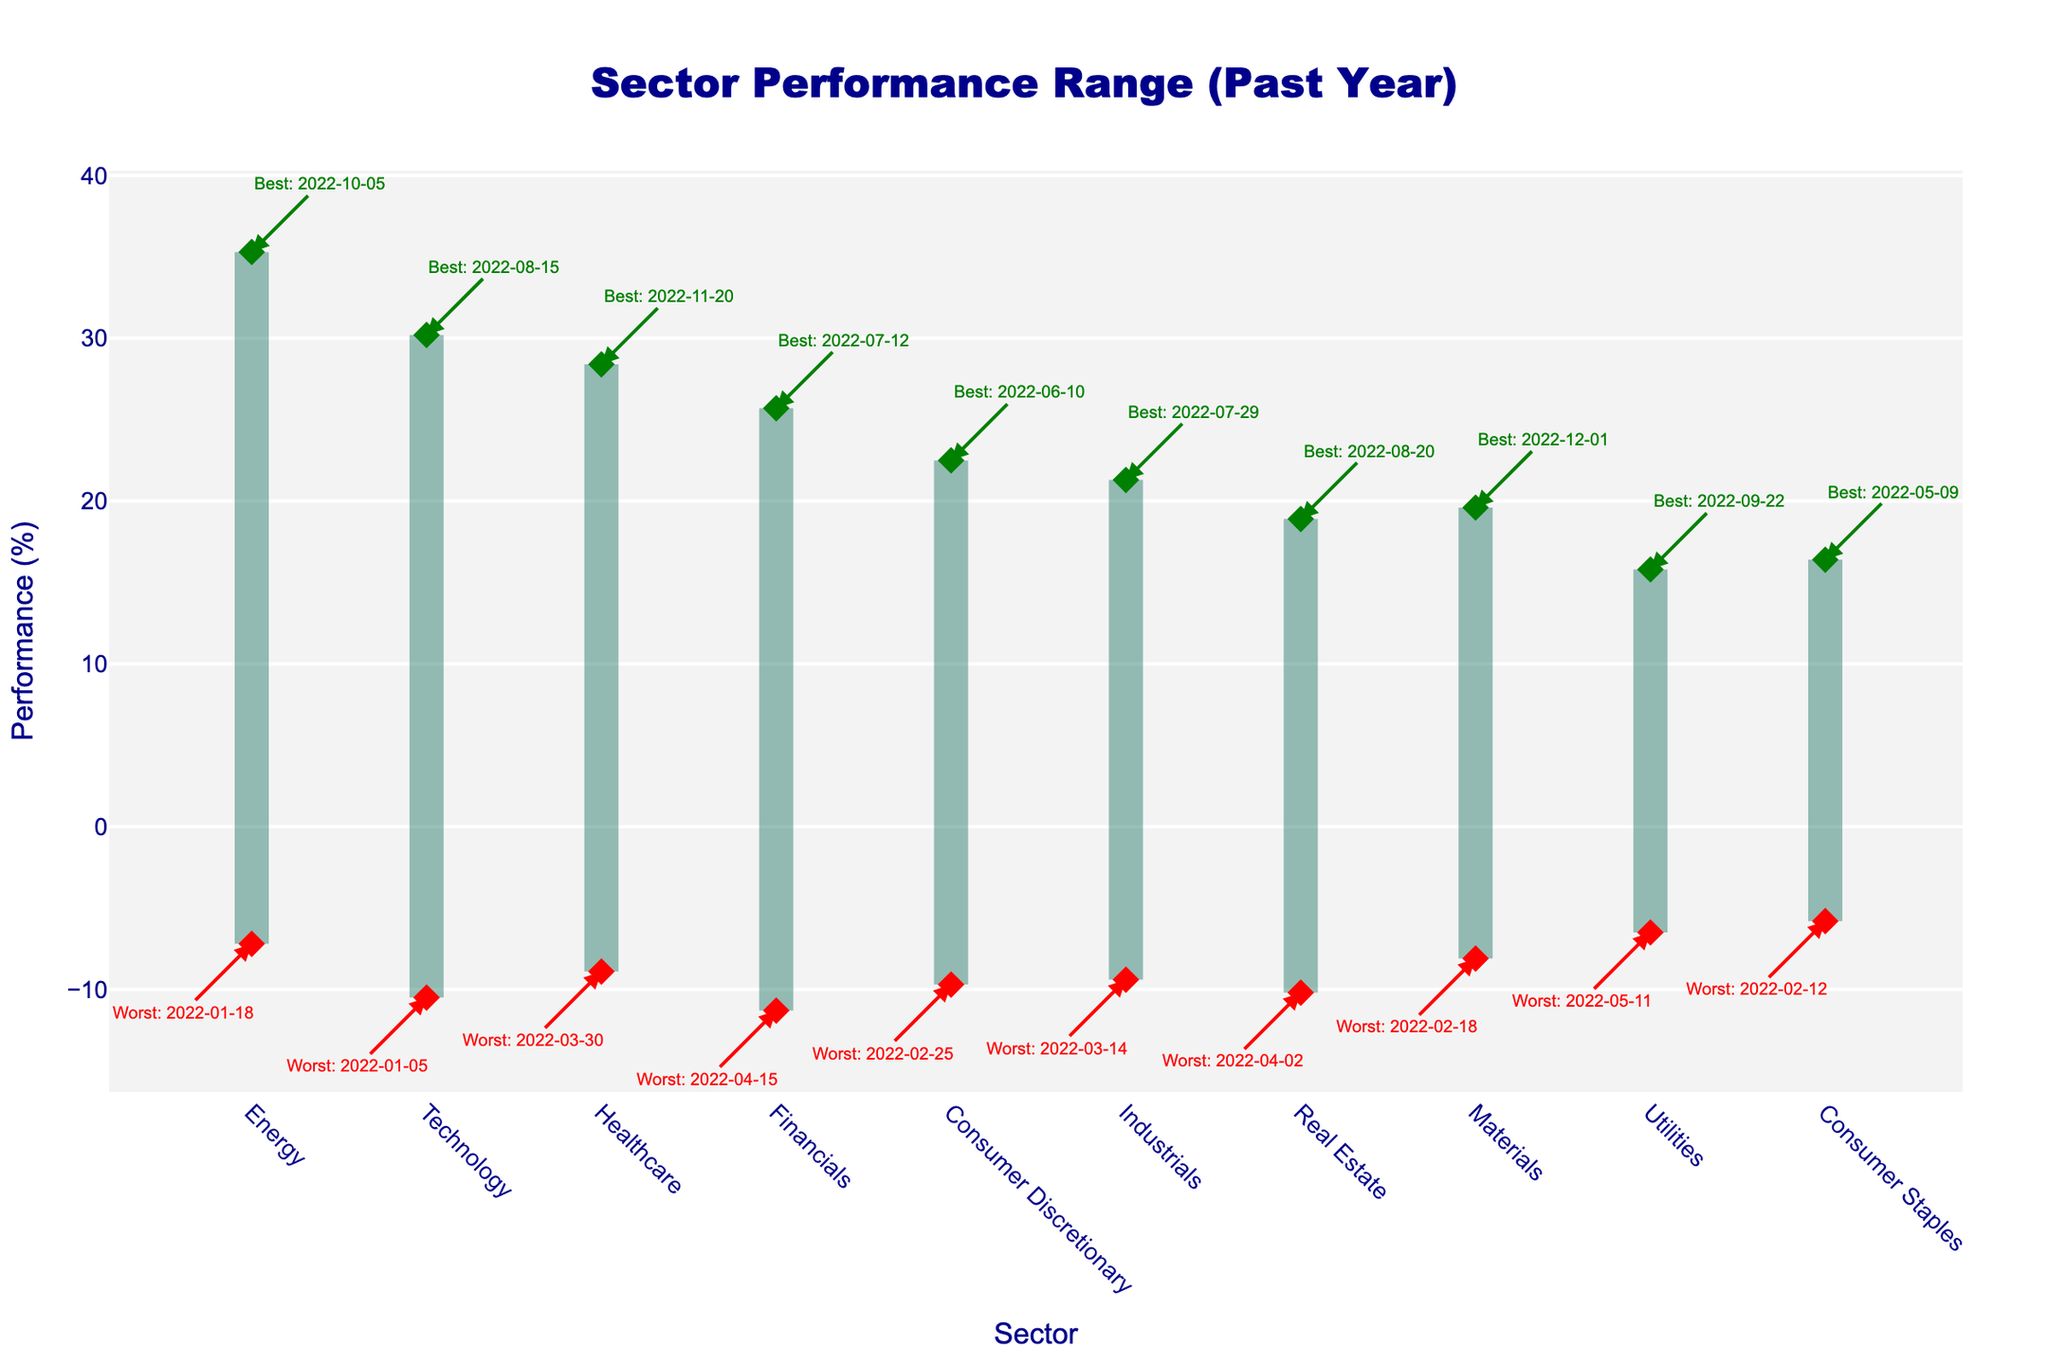What's the title of the chart? The title of the chart is prominently displayed at the top of the figure and reads "Sector Performance Range (Past Year)".
Answer: Sector Performance Range (Past Year) Which sector had the best performance and what was the percentage increase? The best performance can be seen from the green marker at the highest position, which corresponds to the Energy sector.
Answer: Energy, 35.3% What was the worst-performing sector, and what was the percentage decline? The worst performance can be identified by the red marker at the lowest point, which is in the Financials sector.
Answer: Financials, -11.3% Which two sectors had the closest best performance percentages? By looking at the positions of the green markers, Healthcare and Technology have closely aligned best performance percentages.
Answer: Healthcare and Technology Calculate the performance range for the Technology sector. The performance range is the difference between the best and worst performance values for the Technology sector: 30.2 (best) - (-10.5) (worst).
Answer: 40.7% On which date did the Energy sector reach its worst performance? The date of the worst performance for the Energy sector is annotated next to its red marker, which is on January 18, 2022.
Answer: January 18, 2022 Is the worst performance for Consumer Staples higher than the worst performance for Financials? By comparing the positions of the red markers for Consumer Staples and Financials, we see that Consumer Staples (-5.8%) is higher (less negative) than Financials (-11.3%).
Answer: Yes Which sector had its best performance on December 1, 2022? The annotation for the best performance on December 1, 2022, is associated with the Materials sector.
Answer: Materials Compare the worst performance of Utilities and Technology. Which sector fared better? By comparing the red markers' positions, Utilities (-6.5%) fared better than Technology (-10.5%).
Answer: Utilities What is the difference in best performance between the Technology and Real Estate sectors? The difference is calculated by subtracting the best performance value of Real Estate (18.9%) from the best performance value of Technology (30.2%).
Answer: 11.3% 